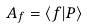Convert formula to latex. <formula><loc_0><loc_0><loc_500><loc_500>A _ { f } = \langle f | P \rangle</formula> 